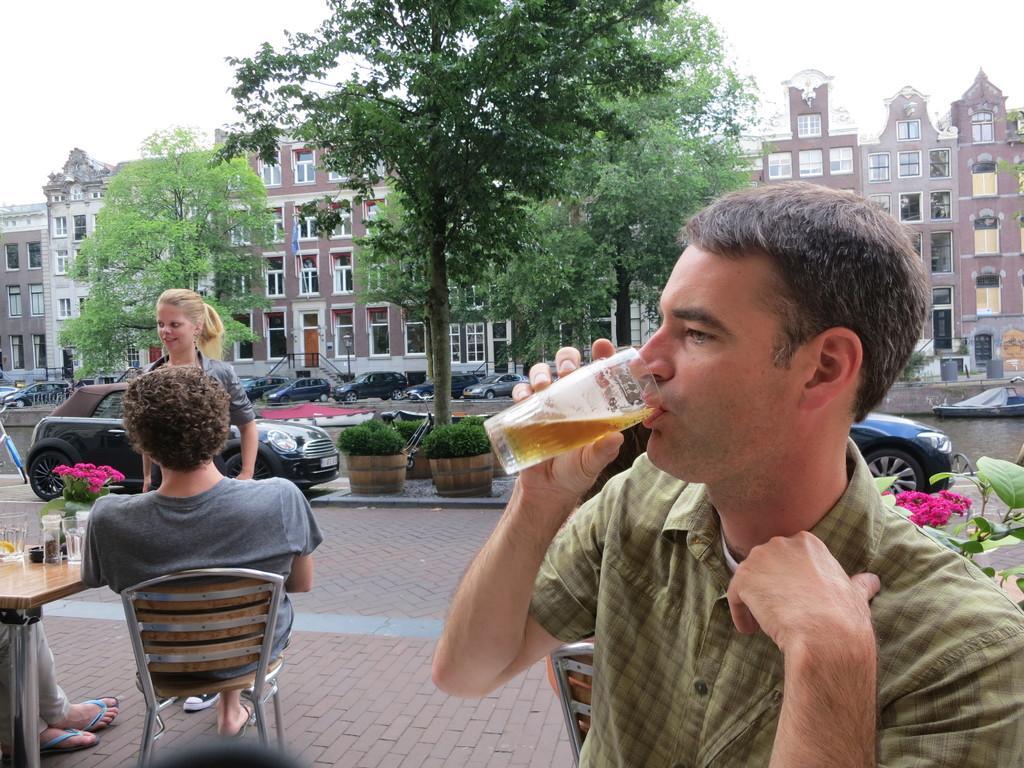Can you describe this image briefly? In this picture we can see two persons sitting on the chairs. This is table. On the table there are glasses. These are the plants. And there are flowers. Here we can see some vehicles on the road. On the background there are trees and these are the buildings. And there is a sky. 